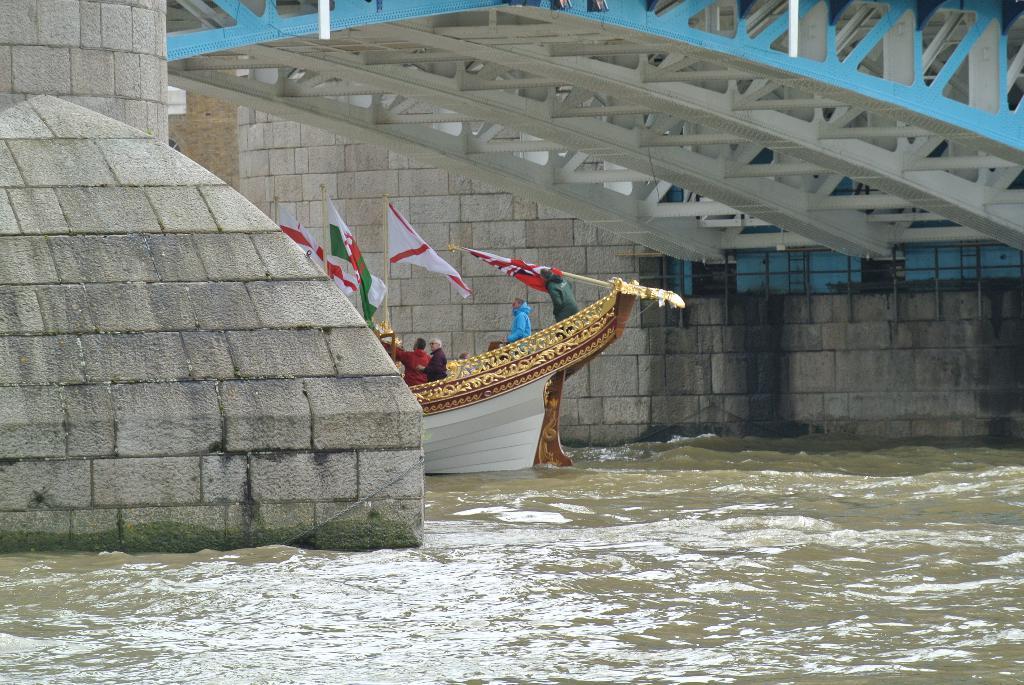How would you summarize this image in a sentence or two? In this image I can see in the middle there is a boat, few people are there and there are flags in it. At the top it looks like a bridge, at the bottom there is water. 